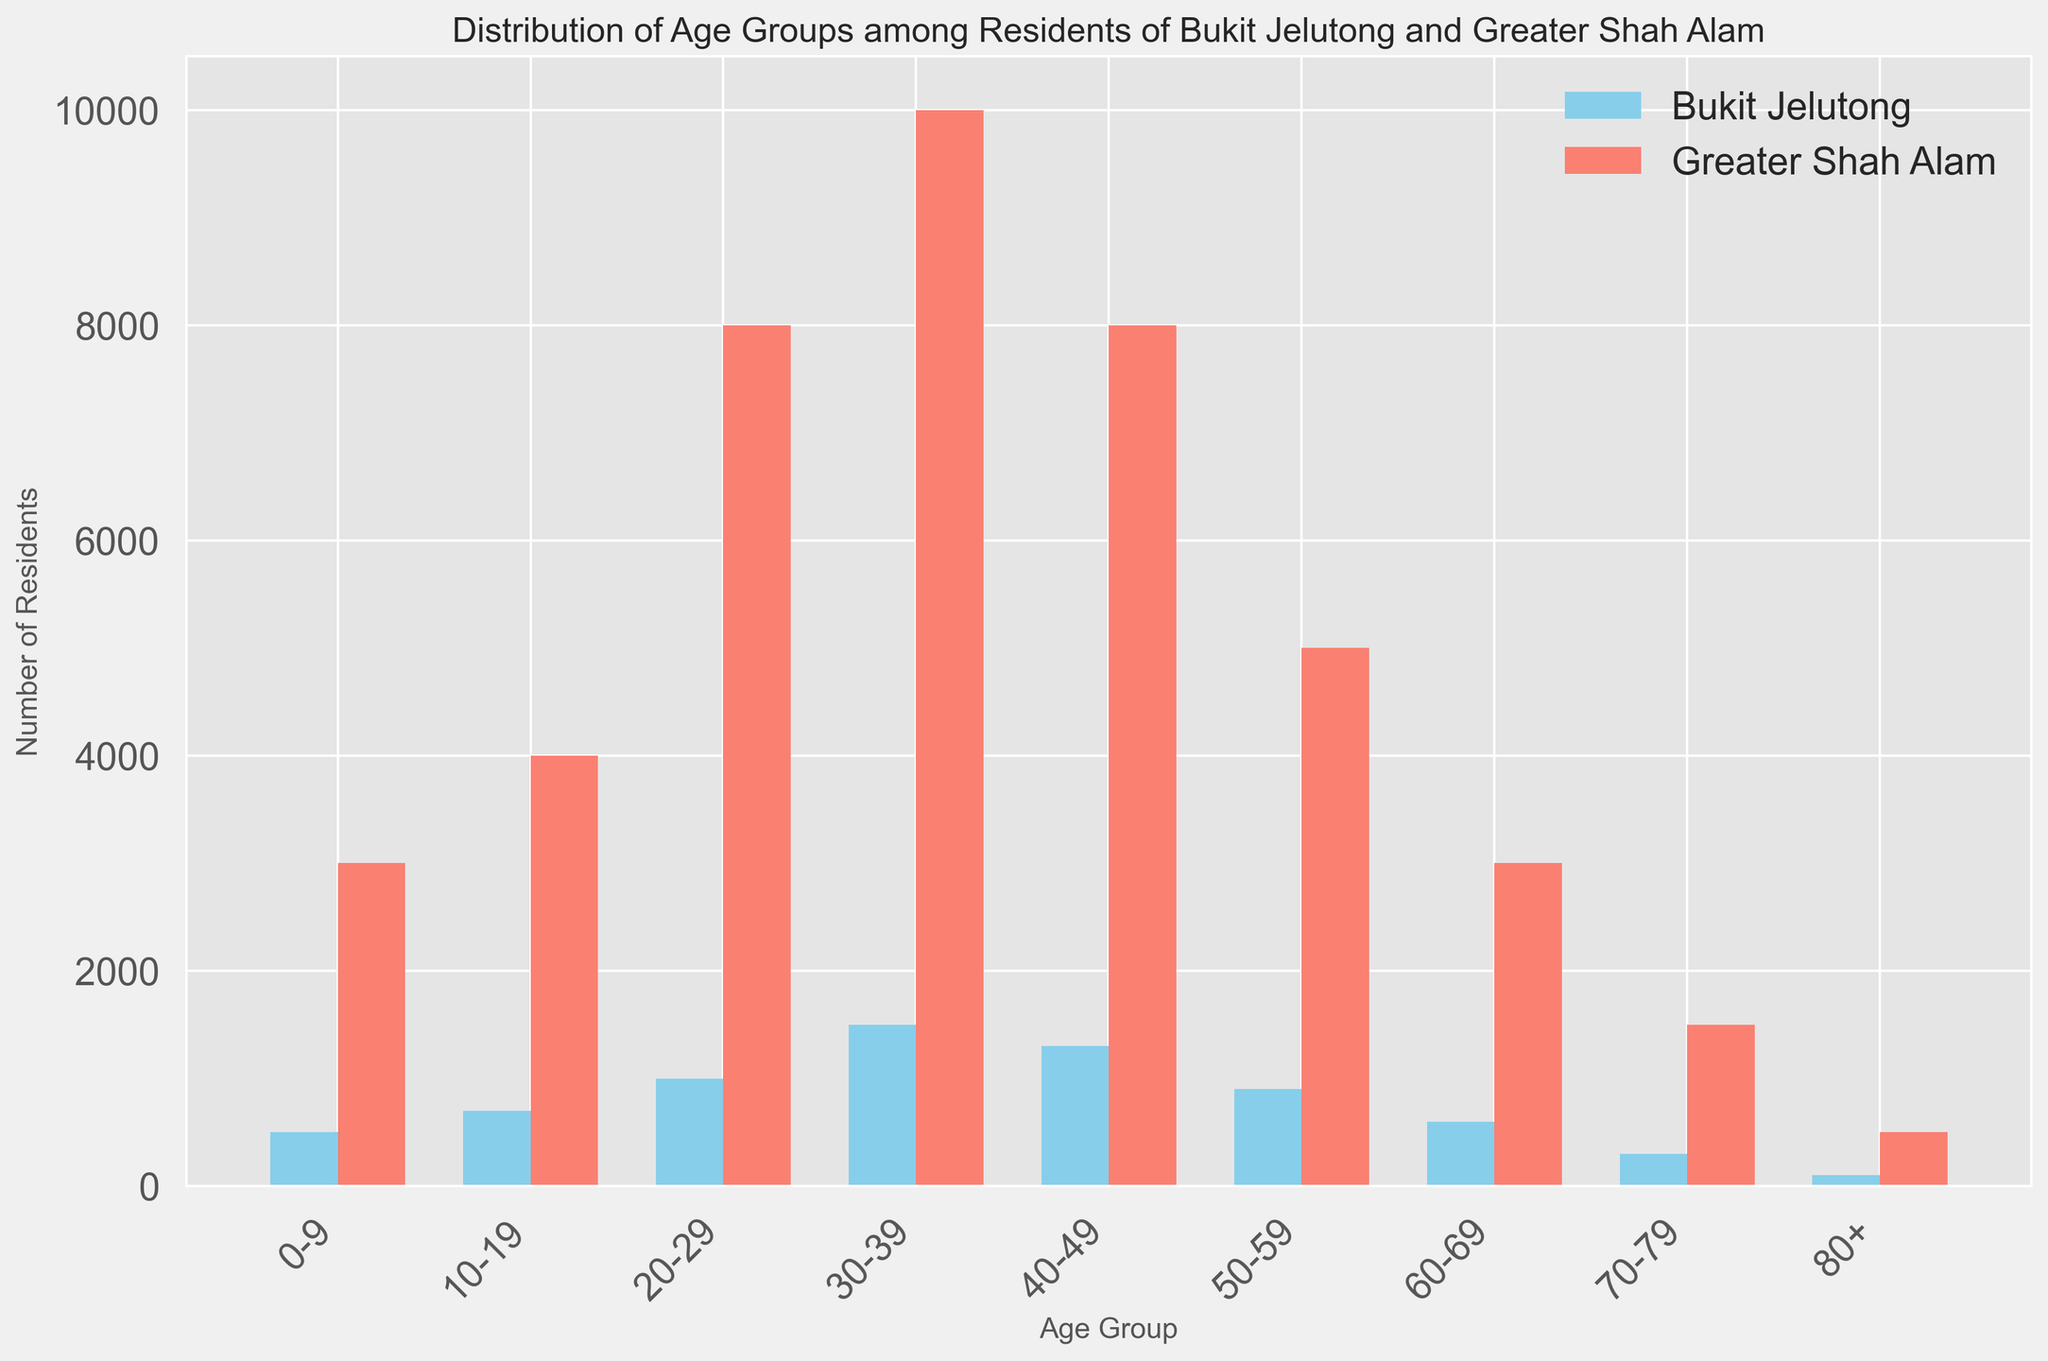which age group has the highest number of residents in Bukit Jelutong? The tallest bar representing Bukit Jelutong is for the age group 30-39 with 1500 residents.
Answer: 30-39 which age group has the smallest difference in population between Bukit Jelutong and Greater Shah Alam? Comparing the heights of the bars, the age group 70-79 shows the smallest difference. Bukit Jelutong has 300 residents, and Greater Shah Alam has 1500, making the difference 1200.
Answer: 70-79 in which age groups does Bukit Jelutong have more residents than Greater Shah Alam? By comparing the heights of the bars, Bukit Jelutong surpasses Greater Shah Alam in the 10-19, 0-9, and 60-69 age groups.
Answer: 0-9, 10-19, 60-69 what's the total number of residents from the age group 20-29 in both Bukit Jelutong and Greater Shah Alam combined? The number of residents in the 20-29 age group is 1000 for Bukit Jelutong and 8000 for Greater Shah Alam. Adding these numbers gives 1000 + 8000 = 9000.
Answer: 9000 which age group shows the biggest absolute difference in population between Bukit Jelutong and Greater Shah Alam? Examining the absolute differences, the age group 30-39 has Bukit Jelutong at 1500 and Greater Shah Alam at 10000, a difference of 8500.
Answer: 30-39 is the number of residents aged 40-49 in Greater Shah Alam more than twice that of Bukit Jelutong? The number of residents aged 40-49 in Greater Shah Alam is 8000, and in Bukit Jelutong, it is 1300. Doubling 1300 gives 2600, and 8000 is more than 2600.
Answer: Yes what is the average population for age groups 50-59 and 60-69 in Bukit Jelutong? The population for 50-59 is 900 and for 60-69 is 600. Their average is (900 + 600) / 2 = 750.
Answer: 750 is there any age group where the population in Greater Shah Alam is exactly four times that of Bukit Jelutong? For the age group 50-59, Bukit Jelutong has 900 residents, and Greater Shah Alam has 5000. Multiplying 900 by 4 gives 3600, which is not equal to 5000. No other ratio matches exactly four times.
Answer: No 